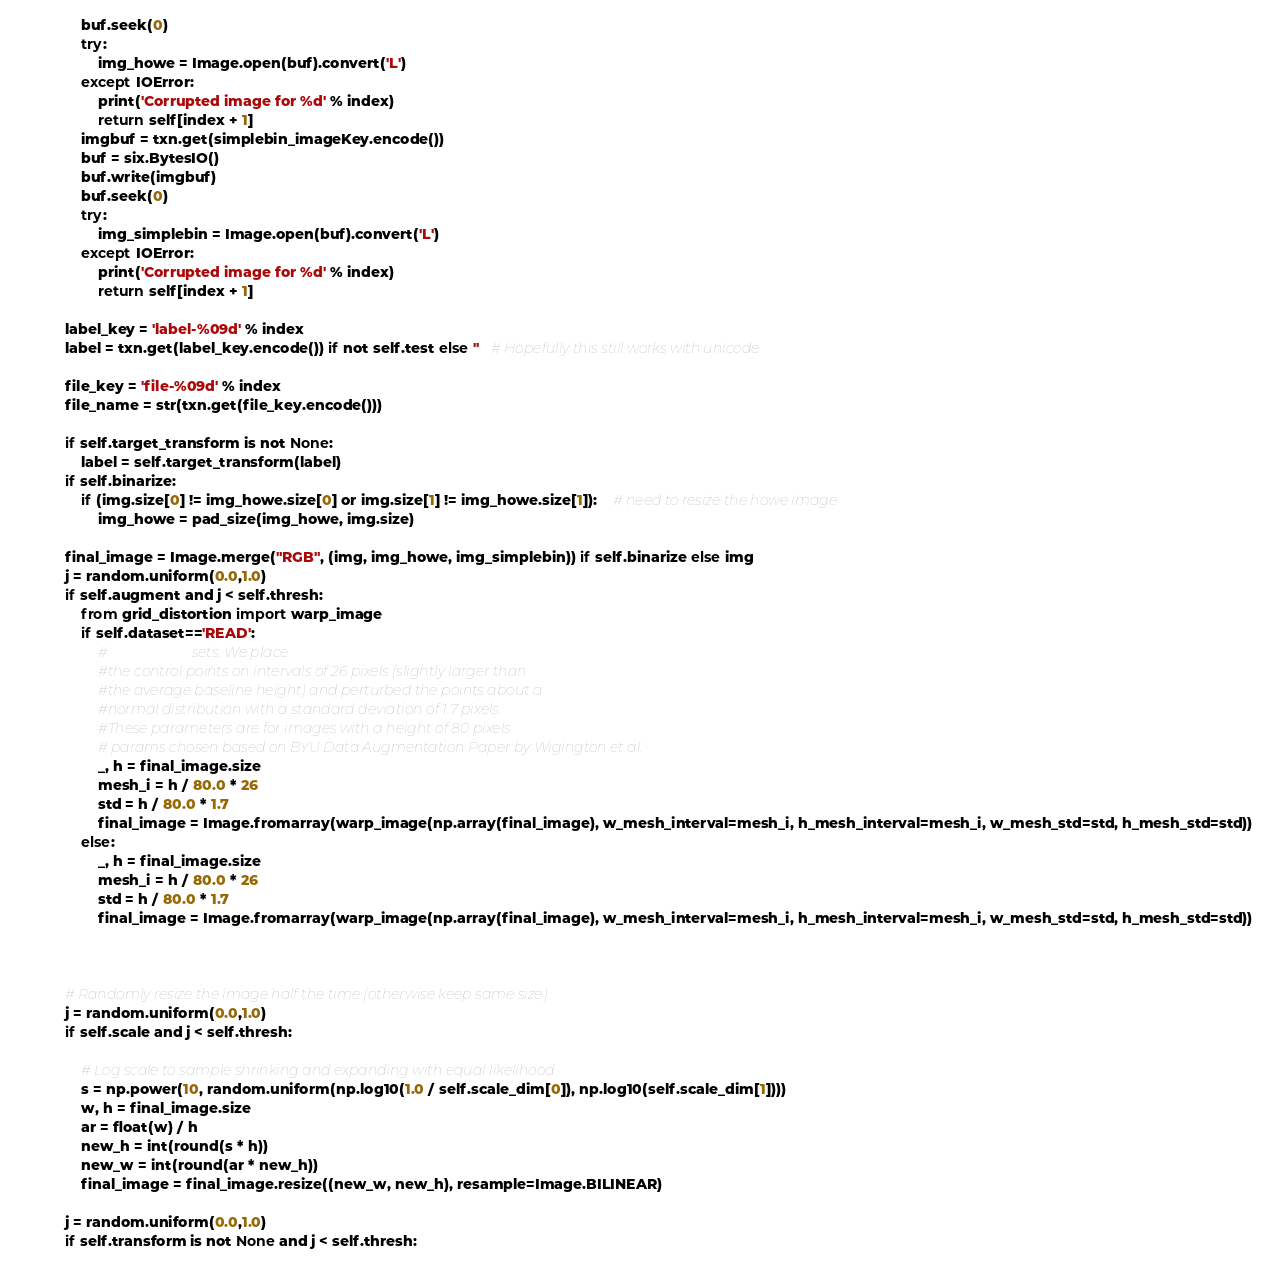<code> <loc_0><loc_0><loc_500><loc_500><_Python_>                buf.seek(0)
                try:
                    img_howe = Image.open(buf).convert('L')
                except IOError:
                    print('Corrupted image for %d' % index)
                    return self[index + 1]
                imgbuf = txn.get(simplebin_imageKey.encode())
                buf = six.BytesIO()
                buf.write(imgbuf)
                buf.seek(0)
                try:
                    img_simplebin = Image.open(buf).convert('L')
                except IOError:
                    print('Corrupted image for %d' % index)
                    return self[index + 1]
            
            label_key = 'label-%09d' % index
            label = txn.get(label_key.encode()) if not self.test else ''   # Hopefully this still works with unicode
            
            file_key = 'file-%09d' % index
            file_name = str(txn.get(file_key.encode())) 

            if self.target_transform is not None:
                label = self.target_transform(label)
            if self.binarize:
                if (img.size[0] != img_howe.size[0] or img.size[1] != img_howe.size[1]):    # need to resize the howe image
                    img_howe = pad_size(img_howe, img.size)
            
            final_image = Image.merge("RGB", (img, img_howe, img_simplebin)) if self.binarize else img
            j = random.uniform(0.0,1.0)
            if self.augment and j < self.thresh:
                from grid_distortion import warp_image
                if self.dataset=='READ':
                    #                        sets. We place
                    #the control points on intervals of 26 pixels (slightly larger than
                    #the average baseline height) and perturbed the points about a
                    #normal distribution with a standard deviation of 1.7 pixels.
                    #These parameters are for images with a height of 80 pixels
                    # params chosen based on BYU Data Augmentation Paper by Wigington et al.
                    _, h = final_image.size
                    mesh_i = h / 80.0 * 26
                    std = h / 80.0 * 1.7
                    final_image = Image.fromarray(warp_image(np.array(final_image), w_mesh_interval=mesh_i, h_mesh_interval=mesh_i, w_mesh_std=std, h_mesh_std=std)) 
                else:
                    _, h = final_image.size
                    mesh_i = h / 80.0 * 26
                    std = h / 80.0 * 1.7
                    final_image = Image.fromarray(warp_image(np.array(final_image), w_mesh_interval=mesh_i, h_mesh_interval=mesh_i, w_mesh_std=std, h_mesh_std=std))

          
            
            # Randomly resize the image half the time (otherwise keep same size)
            j = random.uniform(0.0,1.0)
            if self.scale and j < self.thresh:
                
                # Log scale to sample shrinking and expanding with equal likelihood
                s = np.power(10, random.uniform(np.log10(1.0 / self.scale_dim[0]), np.log10(self.scale_dim[1])))
                w, h = final_image.size
                ar = float(w) / h
                new_h = int(round(s * h))
                new_w = int(round(ar * new_h))
                final_image = final_image.resize((new_w, new_h), resample=Image.BILINEAR)
            
            j = random.uniform(0.0,1.0)
            if self.transform is not None and j < self.thresh:</code> 